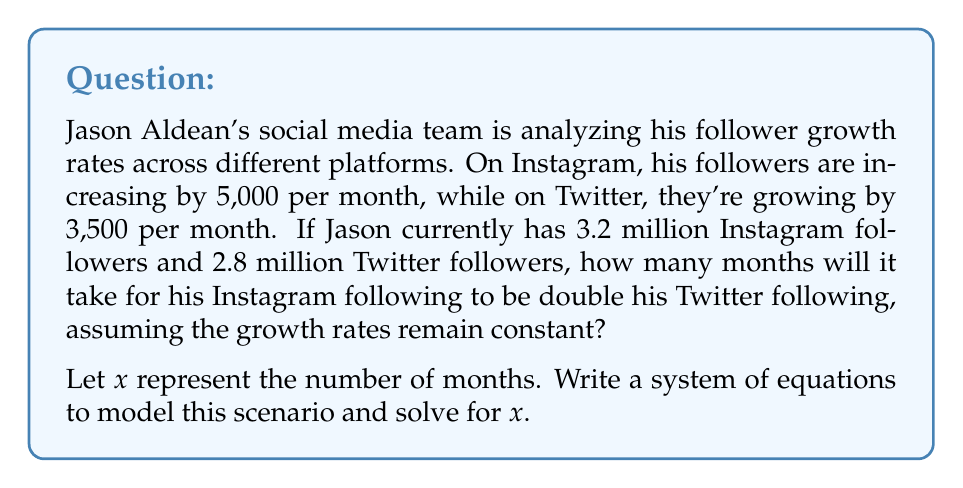Can you answer this question? Let's approach this step-by-step:

1) First, let's set up equations for each platform's follower count after $x$ months:

   Instagram: $3,200,000 + 5,000x$
   Twitter: $2,800,000 + 3,500x$

2) We want to find when Instagram's following is double Twitter's:

   $$(3,200,000 + 5,000x) = 2(2,800,000 + 3,500x)$$

3) Let's expand the right side:

   $$3,200,000 + 5,000x = 5,600,000 + 7,000x$$

4) Subtract 3,200,000 from both sides:

   $$5,000x = 2,400,000 + 7,000x$$

5) Subtract 7,000x from both sides:

   $$-2,000x = 2,400,000$$

6) Divide both sides by -2,000:

   $$x = -1,200$$

7) Since time can't be negative, and we're starting from the current follower counts, this negative result means it's impossible for Instagram to become double Twitter under these growth rates.

To verify, let's check the ratio of Instagram to Twitter followers after a very long time, say 1,000 months:

Instagram: $3,200,000 + 5,000(1000) = 8,200,000$
Twitter: $2,800,000 + 3,500(1000) = 6,300,000$

Ratio: $8,200,000 / 6,300,000 \approx 1.30$

This ratio is less than 2, confirming our conclusion.
Answer: It is impossible for Jason Aldean's Instagram following to become double his Twitter following under the given growth rates. 